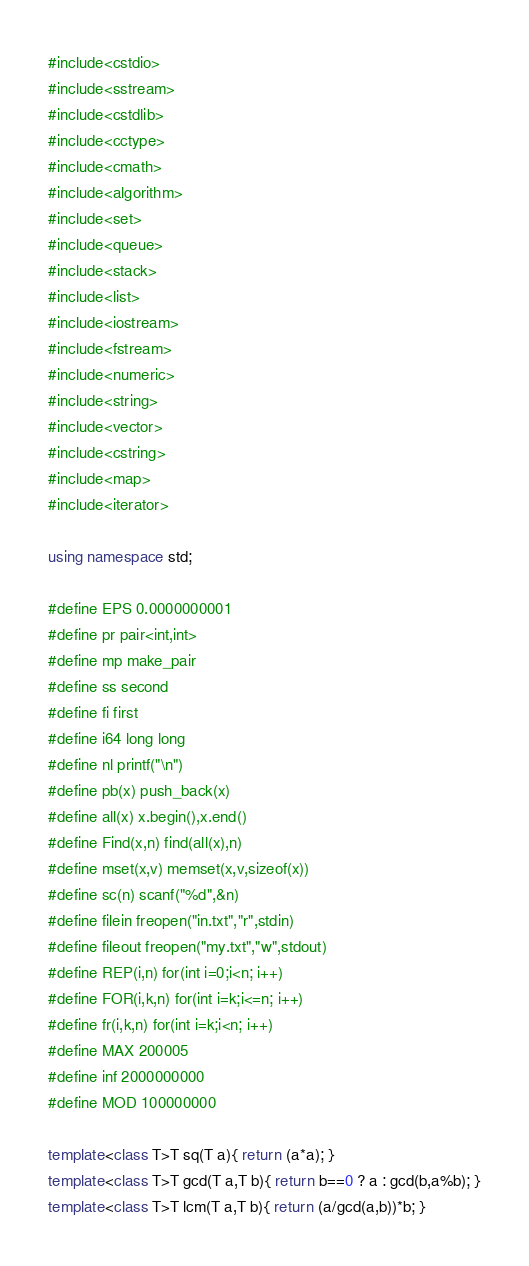Convert code to text. <code><loc_0><loc_0><loc_500><loc_500><_C++_>#include<cstdio>
#include<sstream>
#include<cstdlib>
#include<cctype>
#include<cmath>
#include<algorithm>
#include<set>
#include<queue>
#include<stack>
#include<list>
#include<iostream>
#include<fstream>
#include<numeric>
#include<string>
#include<vector>
#include<cstring>
#include<map>
#include<iterator>

using namespace std;

#define EPS 0.0000000001
#define pr pair<int,int>
#define mp make_pair
#define ss second
#define fi first
#define i64 long long
#define nl printf("\n")
#define pb(x) push_back(x)
#define all(x) x.begin(),x.end()
#define Find(x,n) find(all(x),n)
#define mset(x,v) memset(x,v,sizeof(x))
#define sc(n) scanf("%d",&n)
#define filein freopen("in.txt","r",stdin)
#define fileout freopen("my.txt","w",stdout)
#define REP(i,n) for(int i=0;i<n; i++)
#define FOR(i,k,n) for(int i=k;i<=n; i++)
#define fr(i,k,n) for(int i=k;i<n; i++)
#define MAX 200005
#define inf 2000000000
#define MOD 100000000

template<class T>T sq(T a){ return (a*a); }
template<class T>T gcd(T a,T b){ return b==0 ? a : gcd(b,a%b); }
template<class T>T lcm(T a,T b){ return (a/gcd(a,b))*b; }</code> 